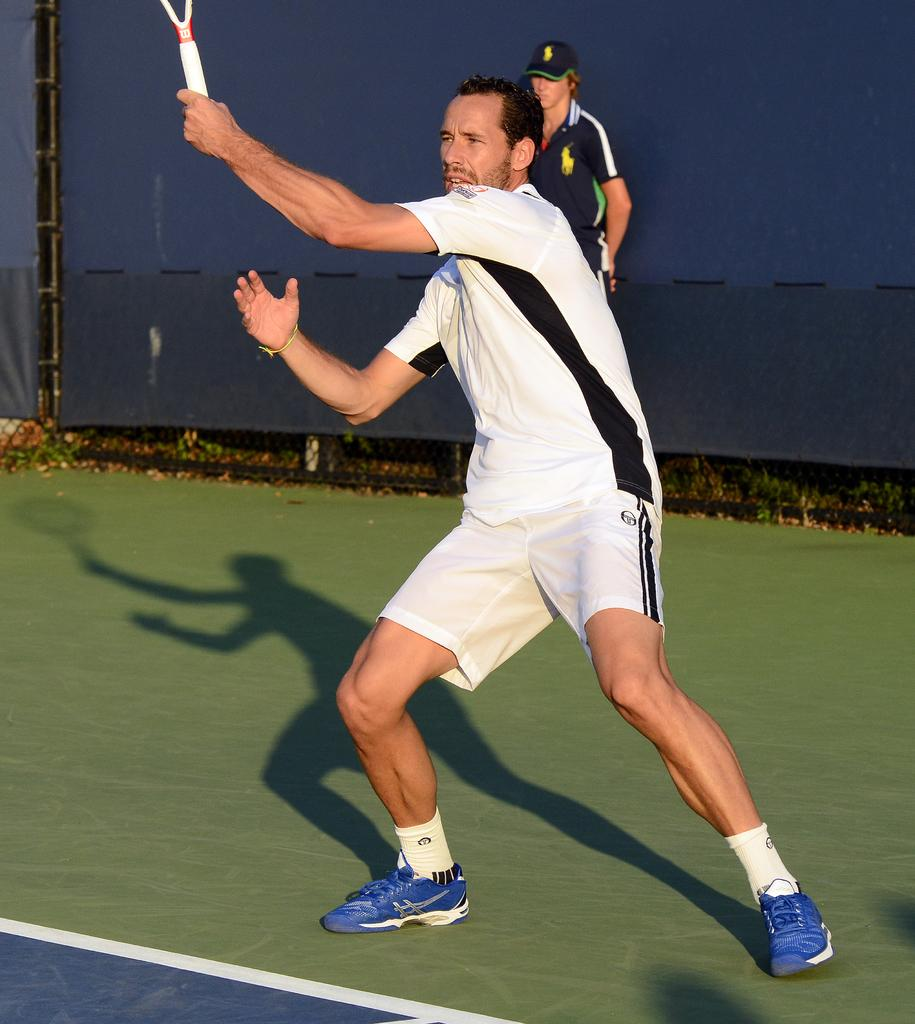What is the main subject of the image? There is a man standing in the image. What is the man wearing? The man is wearing sportswear. Can you describe the person in the background of the image? The person in the background is wearing a cap. What type of stew is being prepared by the giants in the image? There are no giants or stew present in the image. What color is the powder that the man is holding in the image? There is no powder visible in the image; the man is wearing sportswear. 